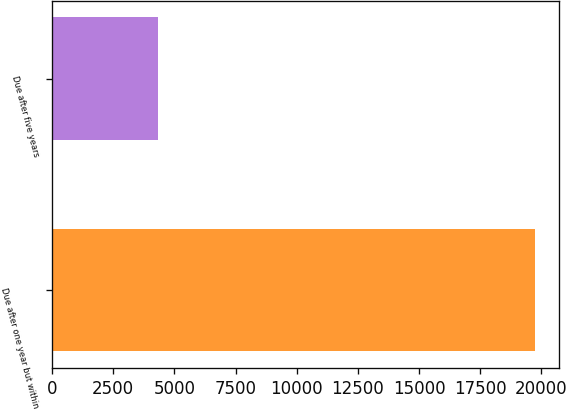Convert chart. <chart><loc_0><loc_0><loc_500><loc_500><bar_chart><fcel>Due after one year but within<fcel>Due after five years<nl><fcel>19722<fcel>4345<nl></chart> 